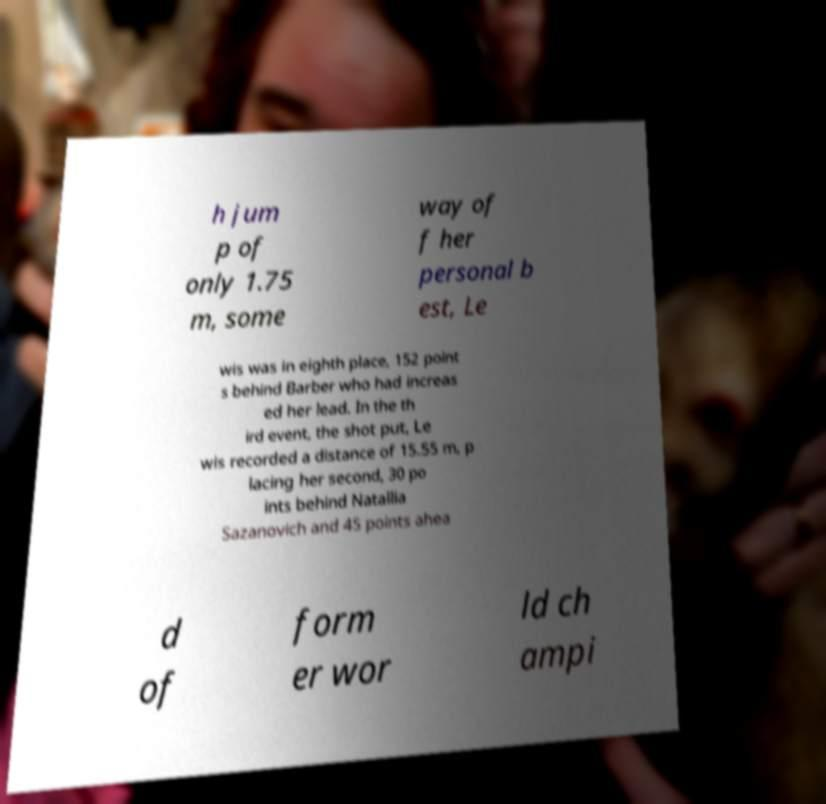For documentation purposes, I need the text within this image transcribed. Could you provide that? h jum p of only 1.75 m, some way of f her personal b est, Le wis was in eighth place, 152 point s behind Barber who had increas ed her lead. In the th ird event, the shot put, Le wis recorded a distance of 15.55 m, p lacing her second, 30 po ints behind Natallia Sazanovich and 45 points ahea d of form er wor ld ch ampi 